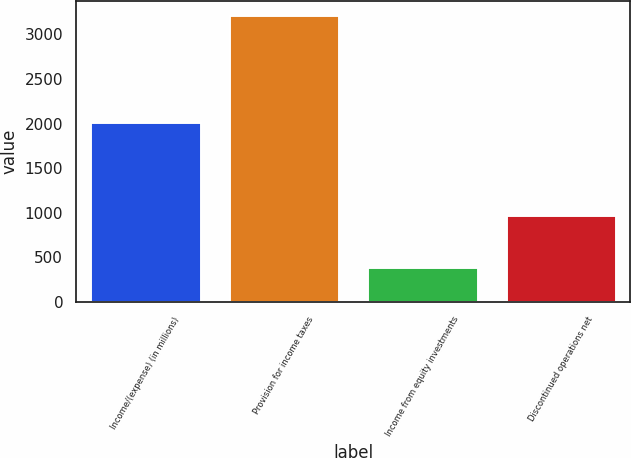Convert chart to OTSL. <chart><loc_0><loc_0><loc_500><loc_500><bar_chart><fcel>Income/(expense) (in millions)<fcel>Provision for income taxes<fcel>Income from equity investments<fcel>Discontinued operations net<nl><fcel>2013<fcel>3214<fcel>395<fcel>971<nl></chart> 